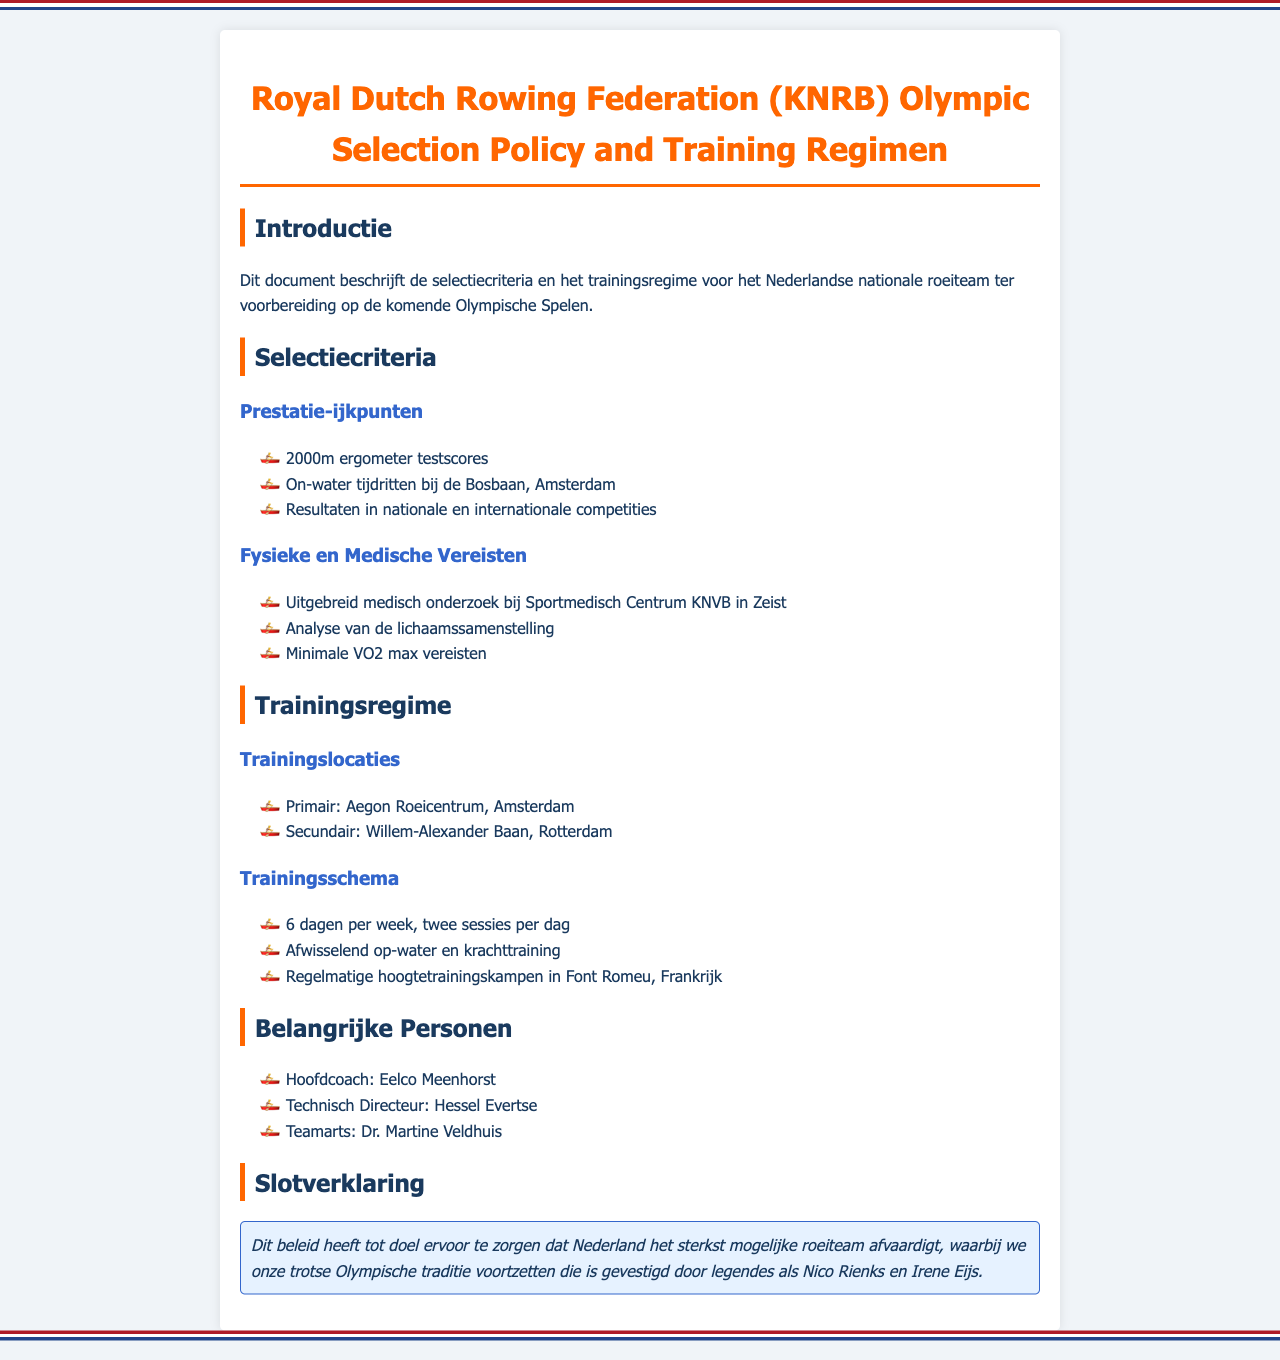what are the performance benchmarks? The performance benchmarks are listed under "Prestatie-ijkpunten" in the document, specifically highlighting the tests and competitions.
Answer: 2000m ergometer testscores, On-water tijdritten bij de Bosbaan, Amsterdam, Resultaten in nationale en internationale competities who is the head coach of the team? The document specifies the key individuals responsible for the national rowing team, including the head coach.
Answer: Eelco Meenhorst how many training days are scheduled per week? The training regimen mentions the frequency of training sessions within the schedule.
Answer: 6 dagen where is the primary training location? The document outlines the main training sites for the rowing team, specifically indicating the primary location.
Answer: Aegon Roeicentrum, Amsterdam what is the purpose of the policy document? The closing statement of the document clarifies the overall intent and goals behind the creation of the policy.
Answer: ervoor te zorgen dat Nederland het sterkst mogelijke roeiteam afvaardigt what are the training sessions per day? The training schedule details the number of sessions undertaken each training day.
Answer: twee sessies per dag what medical assessment is required? The physical and medical requirements section specifies the type of medical examination necessary for selection.
Answer: Uitgebreid medisch onderzoek who is the team doctor? The document lists important personnel, including the medically responsible personnel for the team.
Answer: Dr. Martine Veldhuis 